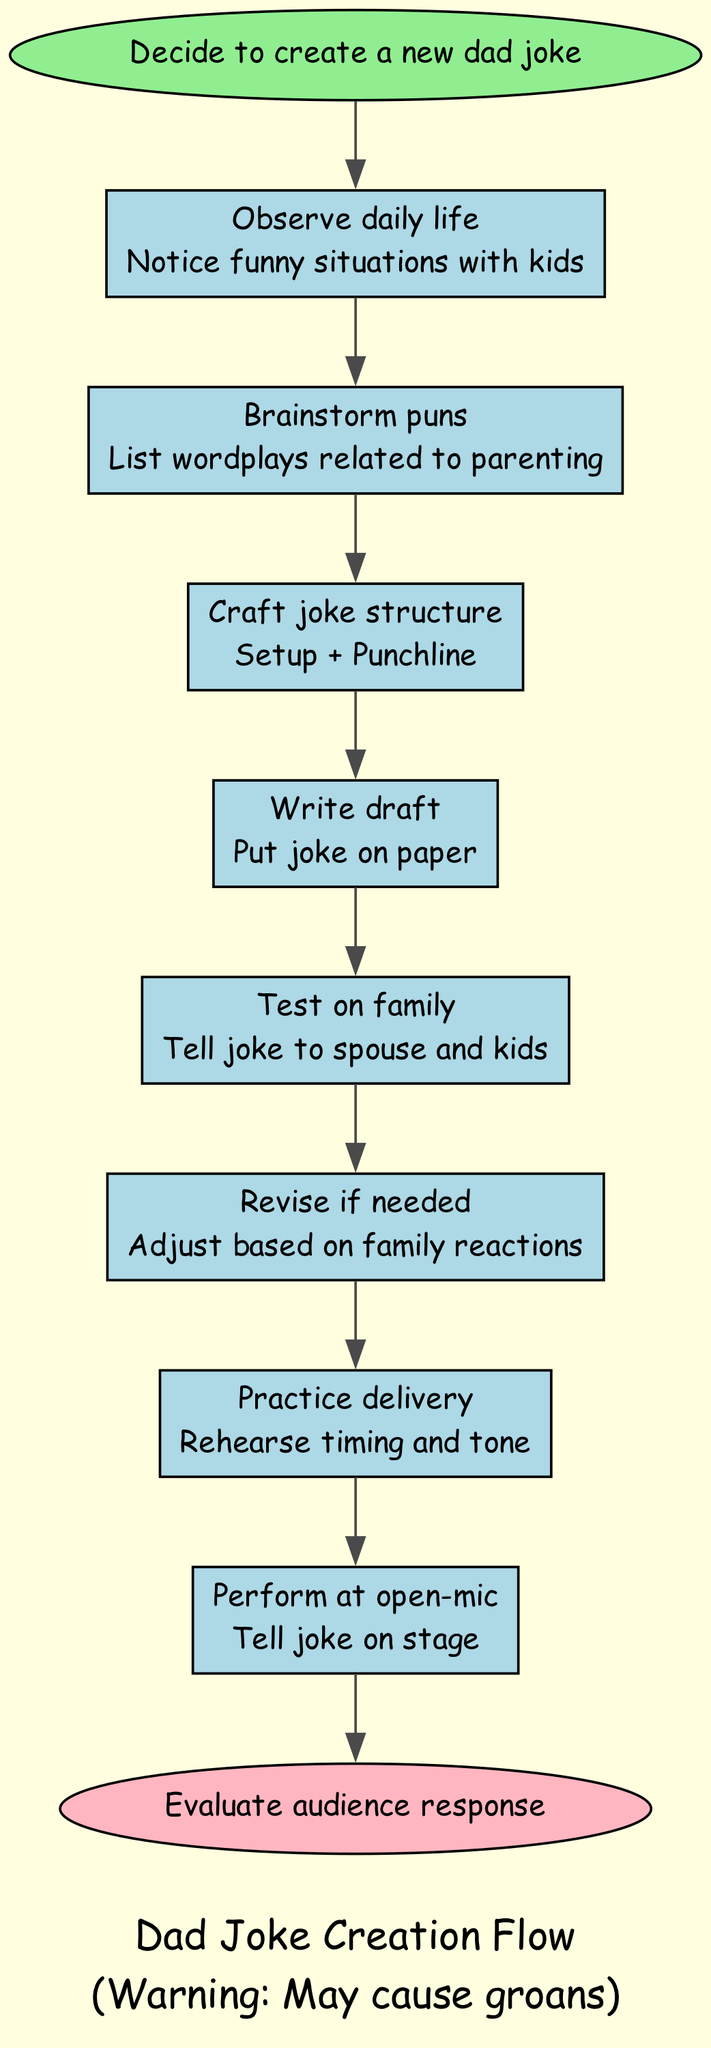What is the first step in the diagram? The first step in the flowchart is labeled as "Decide to create a new dad joke," which is directly connected to the start node. Thus, it is the initial action to take according to the instruction flow.
Answer: Decide to create a new dad joke How many steps are there in total? The flowchart provides a series of steps that progress from the start to the end, which includes a total of 8 steps that are clearly listed in the steps section of the diagram.
Answer: 8 What is the last step in the diagram? The end of the flowchart concludes with the step labeled "Evaluate audience response," which is connected to the last of the instructional steps listed above. This indicates it is the final action after performing.
Answer: Evaluate audience response Which step follows "Write draft"? In the flow of the diagram, the step that follows "Write draft" is "Test on family." This is established by tracing the edges that connect the nodes.
Answer: Test on family What action is suggested after "Revise if needed"? After "Revise if needed," the next action in the flowchart is "Practice delivery." This connection flows naturally through the steps outlined in the diagram about creating and practicing a dad joke.
Answer: Practice delivery What happens before "Perform at open-mic"? The action that occurs just before "Perform at open-mic" is "Practice delivery." This direct link is shown in the flow of sequential steps leading up to the performance.
Answer: Practice delivery How does one start brainstorming for a dad joke? To begin brainstorming for a dad joke, the flowchart suggests the action of "Brainstorm puns," which involves creating a list of parenting-related wordplays. This is a logical step following the observation phase.
Answer: Brainstorm puns Which step involves feedback from family members? The step that requires feedback from family members is "Test on family," where the created joke is shared with the spouse and kids for their reactions. This is an important step in determining a joke's effectiveness.
Answer: Test on family 